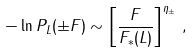Convert formula to latex. <formula><loc_0><loc_0><loc_500><loc_500>- \ln P _ { L } ( \pm F ) \sim \left [ \frac { F } { F _ { * } ( L ) } \right ] ^ { \eta _ { \pm } } \, ,</formula> 